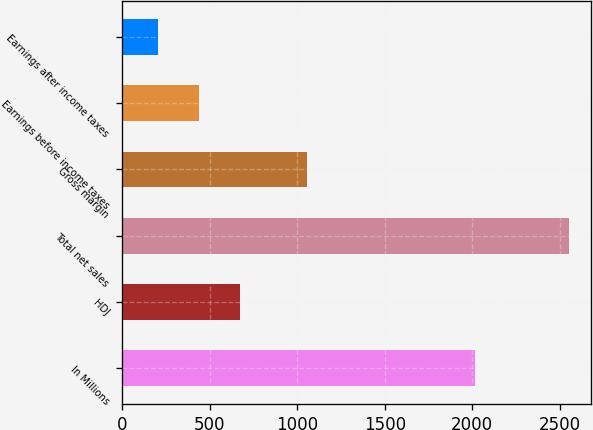Convert chart to OTSL. <chart><loc_0><loc_0><loc_500><loc_500><bar_chart><fcel>In Millions<fcel>HDJ<fcel>Total net sales<fcel>Gross margin<fcel>Earnings before income taxes<fcel>Earnings after income taxes<nl><fcel>2013<fcel>671.82<fcel>2552.7<fcel>1057.3<fcel>436.71<fcel>201.6<nl></chart> 